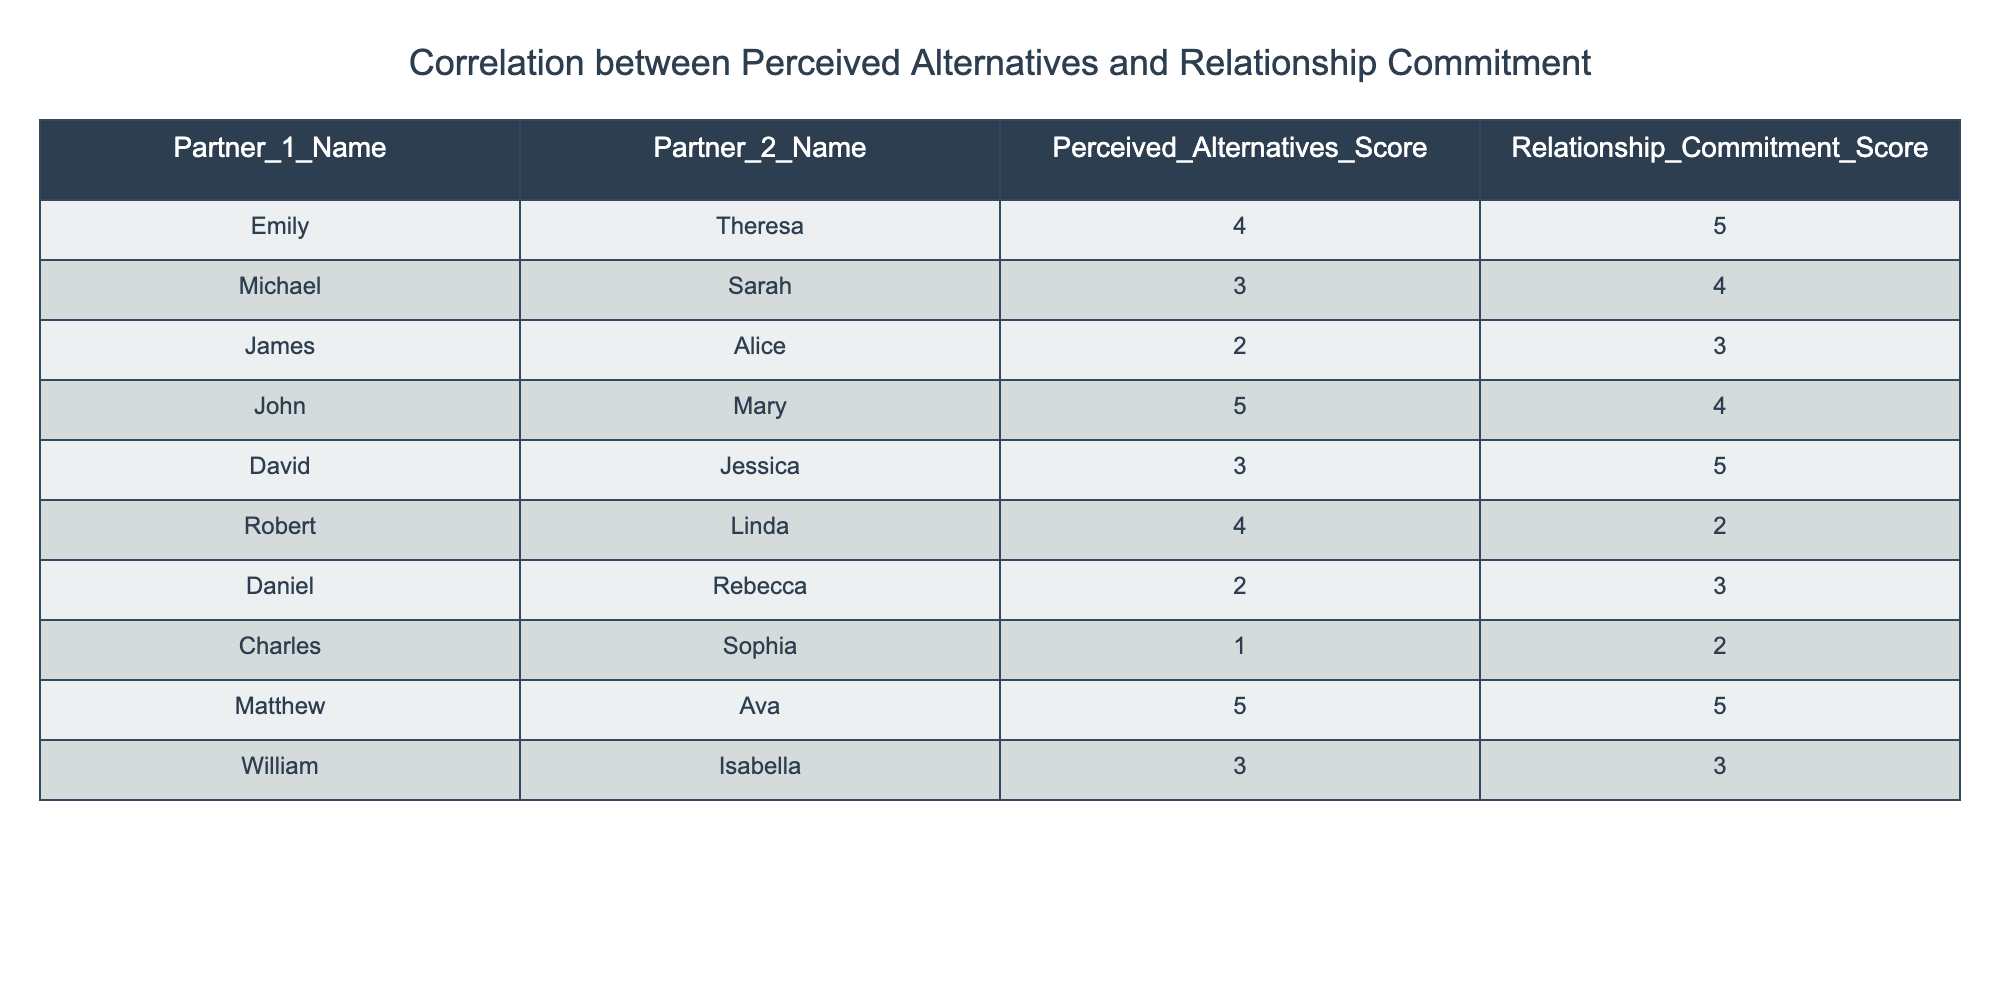What is the highest perceived alternatives score in the table? The highest perceived alternatives score is the maximum value from the "Perceived Alternatives Score" column, which is 5 as seen in the rows for John & Mary and Matthew & Ava.
Answer: 5 What is the relationship commitment score for David and Jessica? Looking at the table under the "Relationship Commitment Score" column, David and Jessica have a score of 5.
Answer: 5 What are the names of the partners with the lowest relationship commitment score? The lowest relationship commitment score in the table is 2, which corresponds to Robert & Linda and Charles & Sophia.
Answer: Robert, Linda, Charles, Sophia What is the average perceived alternatives score for all couples in the table? To find the average perceived alternatives score, sum the scores (4 + 3 + 2 + 5 + 3 + 4 + 2 + 1 + 5 + 3 = 32) and divide by the number of couples (10). Therefore, the average is 32 / 10 = 3.2.
Answer: 3.2 Is there a couple with a perceived alternatives score of 1 and a relationship commitment score higher than 2? Charles & Sophia have a perceived alternatives score of 1 and a relationship commitment score of 2. Since 2 is not higher than 2, the statement is false.
Answer: No Which couple has the highest relationship commitment score among those with a perceived alternatives score of 3? From the couples with a perceived alternatives score of 3, David & Jessica have the highest relationship commitment score of 5, while Michael & Sarah and William & Isabella both have 4 and 3, respectively.
Answer: David, Jessica What is the difference between the highest and lowest relationship commitment scores? The highest relationship commitment score is 5 (from Emily & Theresa and Matthew & Ava), and the lowest is 2 (from Robert & Linda and Charles & Sophia). The difference is 5 - 2 = 3.
Answer: 3 Which couple has the same perceived alternatives and relationship commitment score? By examining the table, the couple James & Alice has a perceived alternatives score of 2 and a relationship commitment score of 3, which are not the same. Thus, there are no couples with the same score.
Answer: None What is the total number of couples with a relationship commitment score of 4 or higher? Counting the rows, the couples with a commitment score of 4 or higher are Emily & Theresa, John & Mary, David & Jessica, and Matthew & Ava. That totals to 4 couples.
Answer: 4 